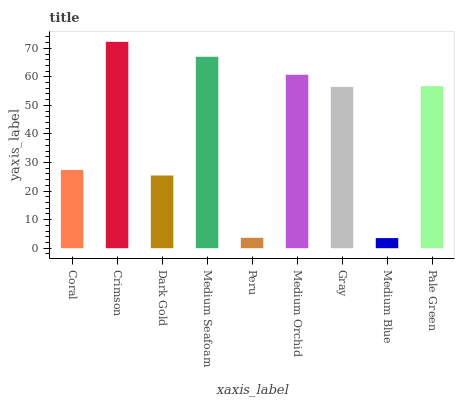Is Medium Blue the minimum?
Answer yes or no. Yes. Is Crimson the maximum?
Answer yes or no. Yes. Is Dark Gold the minimum?
Answer yes or no. No. Is Dark Gold the maximum?
Answer yes or no. No. Is Crimson greater than Dark Gold?
Answer yes or no. Yes. Is Dark Gold less than Crimson?
Answer yes or no. Yes. Is Dark Gold greater than Crimson?
Answer yes or no. No. Is Crimson less than Dark Gold?
Answer yes or no. No. Is Gray the high median?
Answer yes or no. Yes. Is Gray the low median?
Answer yes or no. Yes. Is Medium Seafoam the high median?
Answer yes or no. No. Is Medium Orchid the low median?
Answer yes or no. No. 